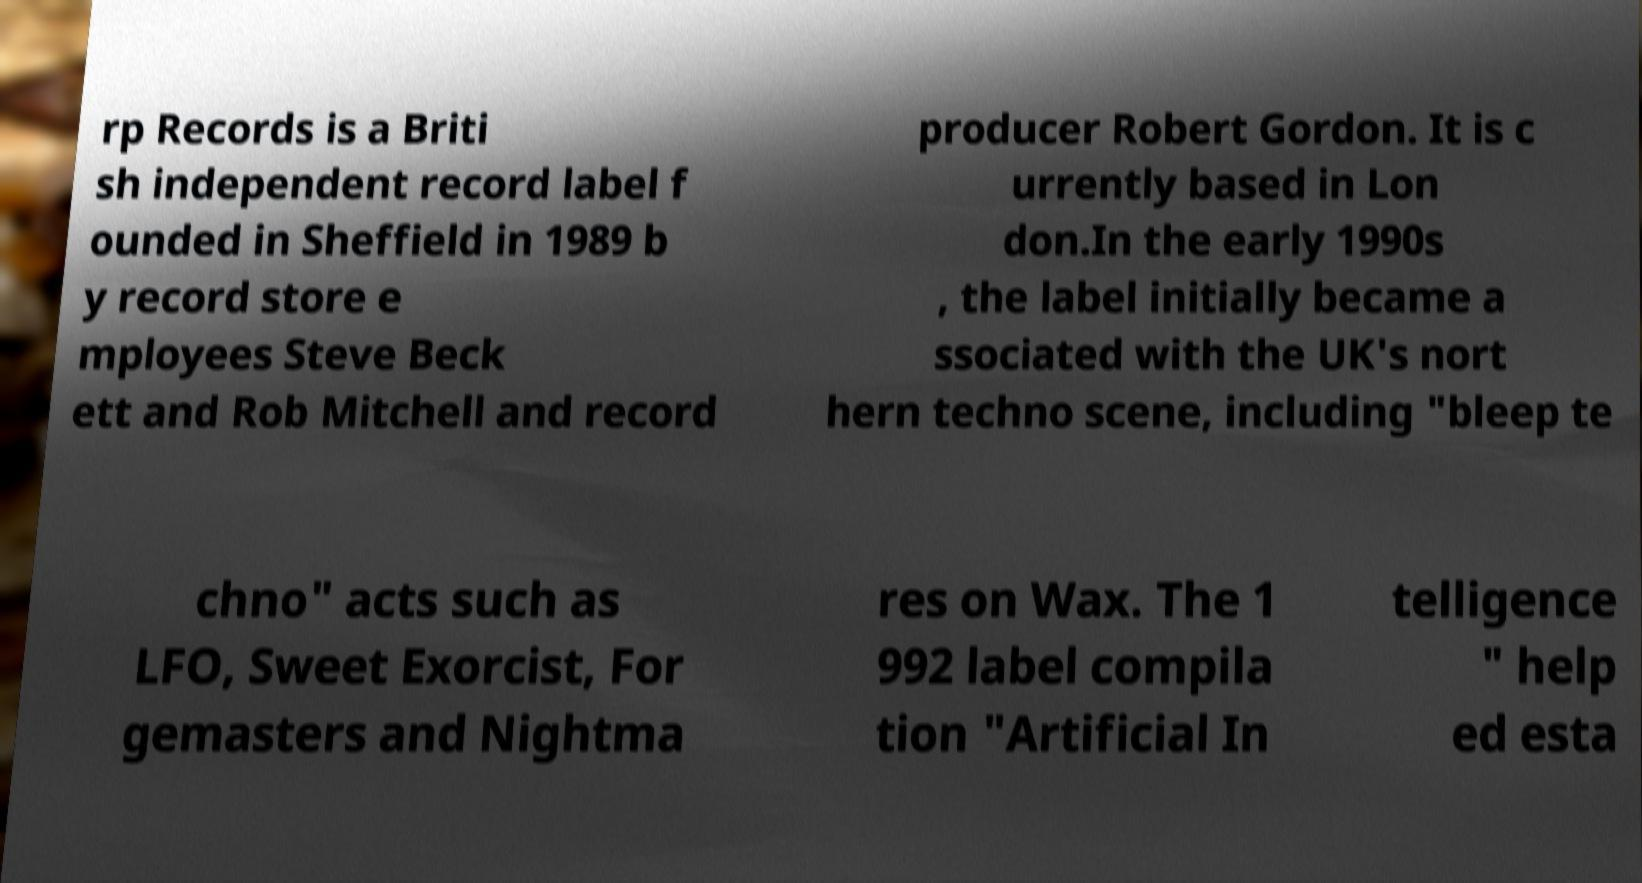Can you read and provide the text displayed in the image?This photo seems to have some interesting text. Can you extract and type it out for me? rp Records is a Briti sh independent record label f ounded in Sheffield in 1989 b y record store e mployees Steve Beck ett and Rob Mitchell and record producer Robert Gordon. It is c urrently based in Lon don.In the early 1990s , the label initially became a ssociated with the UK's nort hern techno scene, including "bleep te chno" acts such as LFO, Sweet Exorcist, For gemasters and Nightma res on Wax. The 1 992 label compila tion "Artificial In telligence " help ed esta 